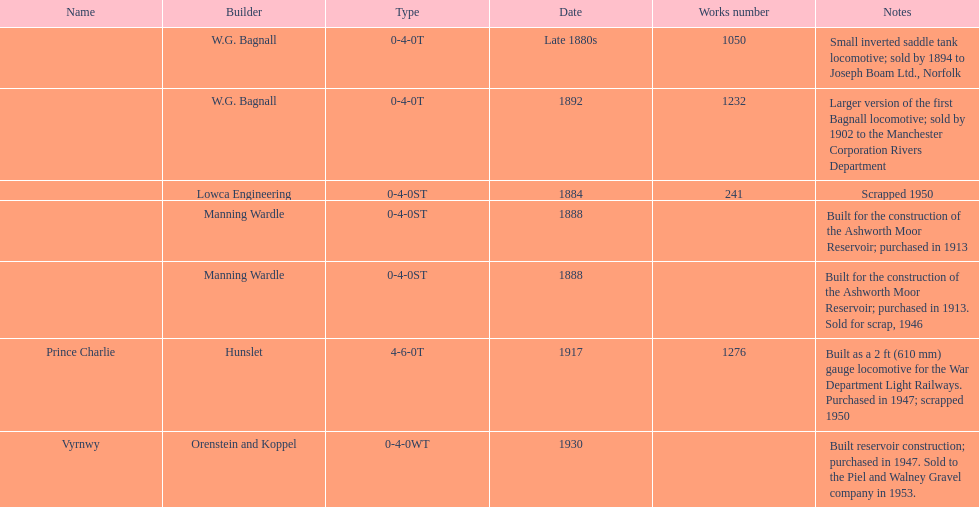Identify all the manufacturers with a locomotive that was scrapped. Lowca Engineering, Manning Wardle, Hunslet. 